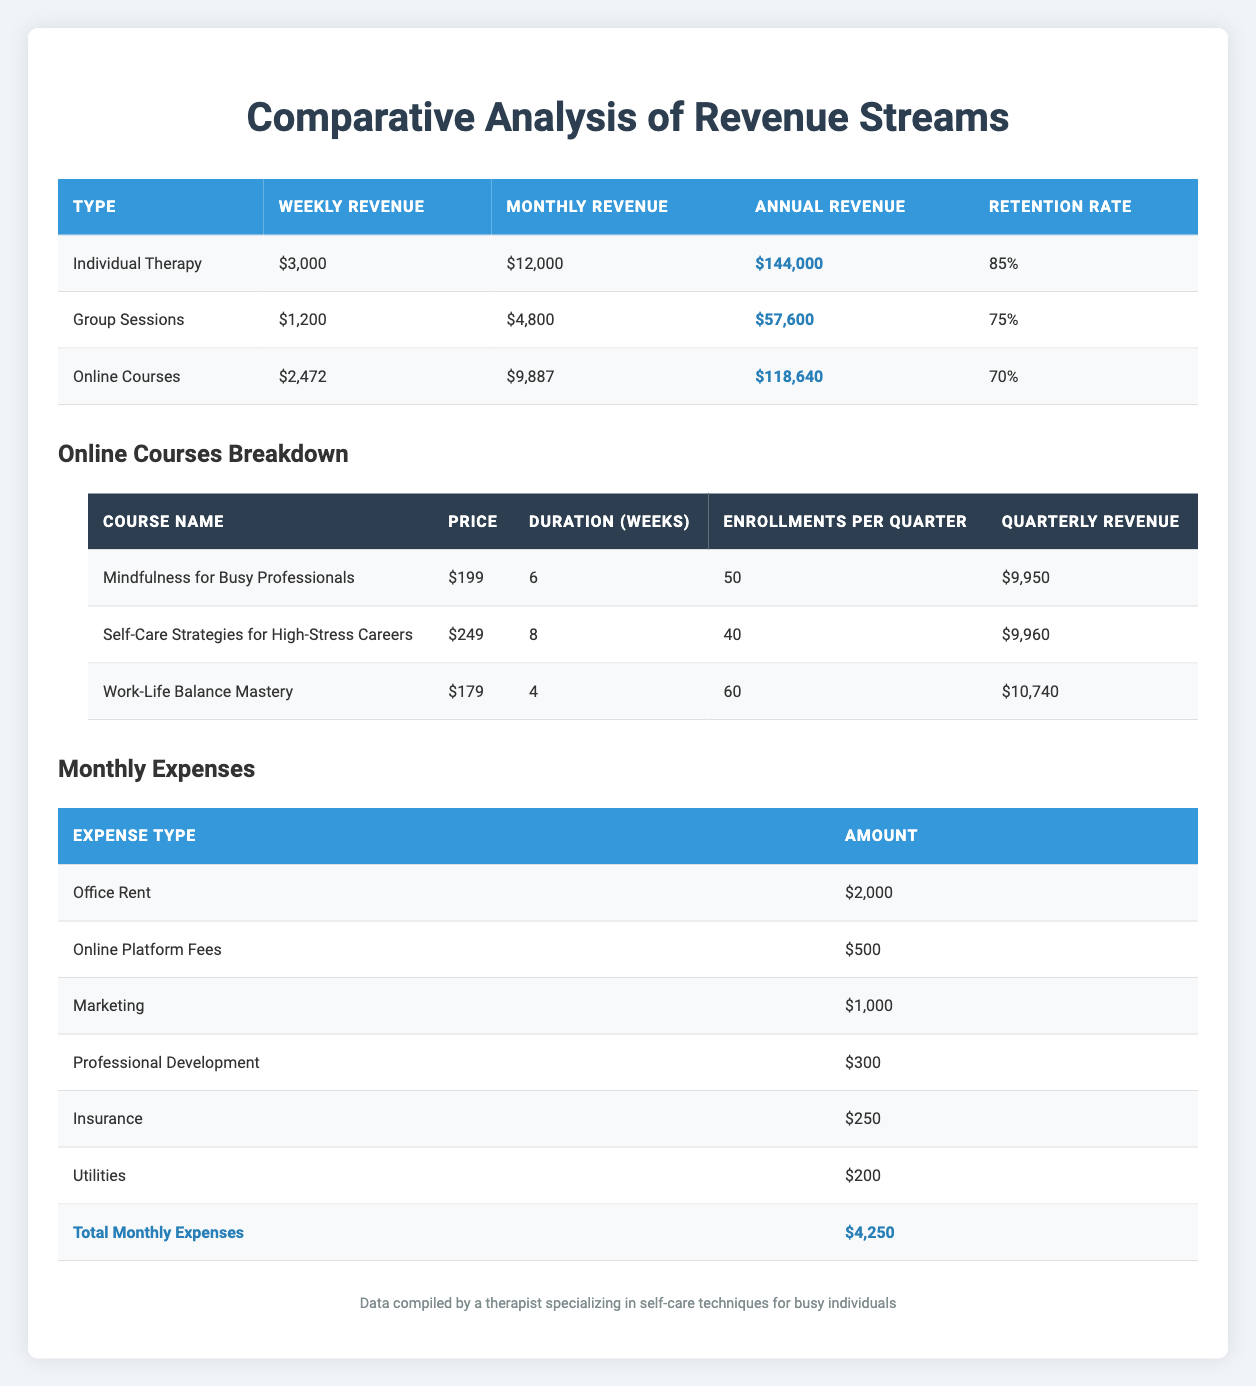What is the annual revenue for Individual Therapy? The table lists the annual revenue for Individual Therapy in the corresponding column, which shows $144,000.
Answer: $144,000 What is the client retention rate for Group Sessions? The client retention rate for Group Sessions is provided directly in the table, which indicates it is 75%.
Answer: 75% Which revenue stream has the highest retention rate? Comparing the retention rates from the table, Individual Therapy has a retention rate of 85%, while Group Sessions has 75% and Online Courses has 70%. Thus, Individual Therapy has the highest retention rate.
Answer: Individual Therapy What is the total revenue generated from Online Courses per year? The annual revenue for Online Courses is displayed in the table and amounts to $118,640.
Answer: $118,640 If you sum the weekly revenues of all three streams, what would that total be? The weekly revenues from the table are: Individual Therapy ($3,000) + Group Sessions ($1,200) + Online Courses (approx. $2,472). Summing these gives $3,000 + $1,200 + $2,472 = $6,672.
Answer: $6,672 Is the annual revenue for Group Sessions greater than $50,000? The annual revenue for Group Sessions is shown in the table as $57,600, which is indeed greater than $50,000.
Answer: Yes What is the average monthly revenue for the three streams? The monthly revenues are: Individual Therapy ($12,000), Group Sessions ($4,800), Online Courses (approx. $9,887). The average is calculated by summing these amounts ($12,000 + $4,800 + $9,887 = $25,687) and dividing by 3, resulting in approximately $8,562.33.
Answer: $8,562.33 Which has a higher total revenue: Individual Therapy or Online Courses? The annual revenue for Individual Therapy is $144,000 and for Online Courses, it is $118,640. Since $144,000 is greater than $118,640, Individual Therapy has a higher total revenue.
Answer: Individual Therapy How much are the total monthly expenses for the practice? The table lists the total monthly expenses as $4,250 in the last row under Monthly Expenses.
Answer: $4,250 